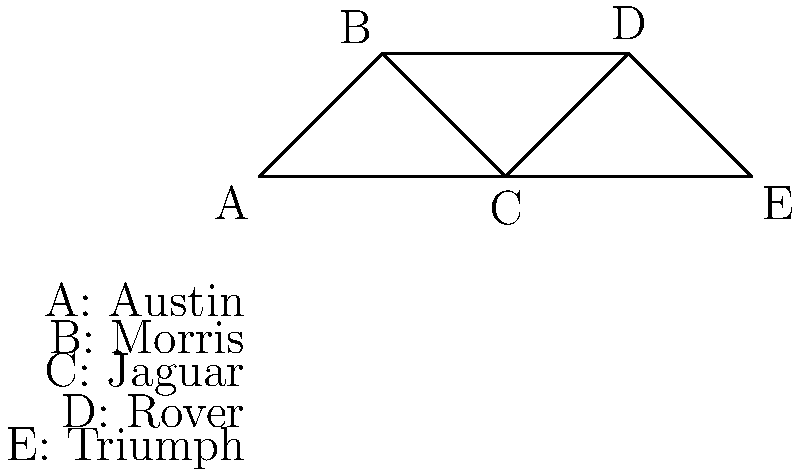In the graph representing the connectivity between automotive manufacturing plants in post-war Britain, what is the minimum number of plants that need to be closed to completely disconnect Austin (A) from Triumph (E)? To solve this problem, we need to find the minimum number of vertices that, when removed, will disconnect vertices A and E. This is known as the vertex connectivity between A and E. Let's approach this step-by-step:

1. Identify all possible paths from A to E:
   - A -> C -> E
   - A -> B -> D -> C -> E
   - A -> C -> D -> E

2. Observe that all paths must go through vertex C.

3. Removing vertex C alone will disconnect A from E.

4. Check if there's a solution with fewer vertex removals:
   - Removing A or E alone doesn't disconnect them from each other.
   - Removing any other single vertex (B or D) doesn't disconnect A from E.

5. Therefore, the minimum number of vertices to be removed is 1, and that vertex is C.

In the context of automotive plants, this means closing the Jaguar plant (C) would be sufficient to completely disconnect Austin (A) from Triumph (E).
Answer: 1 